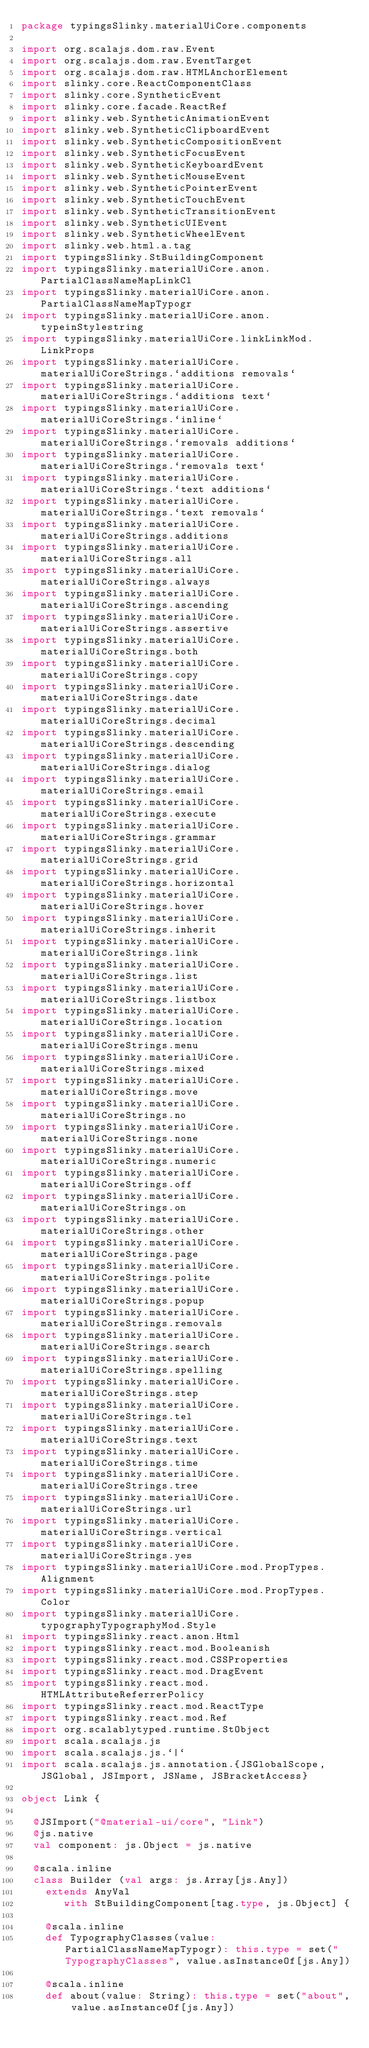Convert code to text. <code><loc_0><loc_0><loc_500><loc_500><_Scala_>package typingsSlinky.materialUiCore.components

import org.scalajs.dom.raw.Event
import org.scalajs.dom.raw.EventTarget
import org.scalajs.dom.raw.HTMLAnchorElement
import slinky.core.ReactComponentClass
import slinky.core.SyntheticEvent
import slinky.core.facade.ReactRef
import slinky.web.SyntheticAnimationEvent
import slinky.web.SyntheticClipboardEvent
import slinky.web.SyntheticCompositionEvent
import slinky.web.SyntheticFocusEvent
import slinky.web.SyntheticKeyboardEvent
import slinky.web.SyntheticMouseEvent
import slinky.web.SyntheticPointerEvent
import slinky.web.SyntheticTouchEvent
import slinky.web.SyntheticTransitionEvent
import slinky.web.SyntheticUIEvent
import slinky.web.SyntheticWheelEvent
import slinky.web.html.a.tag
import typingsSlinky.StBuildingComponent
import typingsSlinky.materialUiCore.anon.PartialClassNameMapLinkCl
import typingsSlinky.materialUiCore.anon.PartialClassNameMapTypogr
import typingsSlinky.materialUiCore.anon.typeinStylestring
import typingsSlinky.materialUiCore.linkLinkMod.LinkProps
import typingsSlinky.materialUiCore.materialUiCoreStrings.`additions removals`
import typingsSlinky.materialUiCore.materialUiCoreStrings.`additions text`
import typingsSlinky.materialUiCore.materialUiCoreStrings.`inline`
import typingsSlinky.materialUiCore.materialUiCoreStrings.`removals additions`
import typingsSlinky.materialUiCore.materialUiCoreStrings.`removals text`
import typingsSlinky.materialUiCore.materialUiCoreStrings.`text additions`
import typingsSlinky.materialUiCore.materialUiCoreStrings.`text removals`
import typingsSlinky.materialUiCore.materialUiCoreStrings.additions
import typingsSlinky.materialUiCore.materialUiCoreStrings.all
import typingsSlinky.materialUiCore.materialUiCoreStrings.always
import typingsSlinky.materialUiCore.materialUiCoreStrings.ascending
import typingsSlinky.materialUiCore.materialUiCoreStrings.assertive
import typingsSlinky.materialUiCore.materialUiCoreStrings.both
import typingsSlinky.materialUiCore.materialUiCoreStrings.copy
import typingsSlinky.materialUiCore.materialUiCoreStrings.date
import typingsSlinky.materialUiCore.materialUiCoreStrings.decimal
import typingsSlinky.materialUiCore.materialUiCoreStrings.descending
import typingsSlinky.materialUiCore.materialUiCoreStrings.dialog
import typingsSlinky.materialUiCore.materialUiCoreStrings.email
import typingsSlinky.materialUiCore.materialUiCoreStrings.execute
import typingsSlinky.materialUiCore.materialUiCoreStrings.grammar
import typingsSlinky.materialUiCore.materialUiCoreStrings.grid
import typingsSlinky.materialUiCore.materialUiCoreStrings.horizontal
import typingsSlinky.materialUiCore.materialUiCoreStrings.hover
import typingsSlinky.materialUiCore.materialUiCoreStrings.inherit
import typingsSlinky.materialUiCore.materialUiCoreStrings.link
import typingsSlinky.materialUiCore.materialUiCoreStrings.list
import typingsSlinky.materialUiCore.materialUiCoreStrings.listbox
import typingsSlinky.materialUiCore.materialUiCoreStrings.location
import typingsSlinky.materialUiCore.materialUiCoreStrings.menu
import typingsSlinky.materialUiCore.materialUiCoreStrings.mixed
import typingsSlinky.materialUiCore.materialUiCoreStrings.move
import typingsSlinky.materialUiCore.materialUiCoreStrings.no
import typingsSlinky.materialUiCore.materialUiCoreStrings.none
import typingsSlinky.materialUiCore.materialUiCoreStrings.numeric
import typingsSlinky.materialUiCore.materialUiCoreStrings.off
import typingsSlinky.materialUiCore.materialUiCoreStrings.on
import typingsSlinky.materialUiCore.materialUiCoreStrings.other
import typingsSlinky.materialUiCore.materialUiCoreStrings.page
import typingsSlinky.materialUiCore.materialUiCoreStrings.polite
import typingsSlinky.materialUiCore.materialUiCoreStrings.popup
import typingsSlinky.materialUiCore.materialUiCoreStrings.removals
import typingsSlinky.materialUiCore.materialUiCoreStrings.search
import typingsSlinky.materialUiCore.materialUiCoreStrings.spelling
import typingsSlinky.materialUiCore.materialUiCoreStrings.step
import typingsSlinky.materialUiCore.materialUiCoreStrings.tel
import typingsSlinky.materialUiCore.materialUiCoreStrings.text
import typingsSlinky.materialUiCore.materialUiCoreStrings.time
import typingsSlinky.materialUiCore.materialUiCoreStrings.tree
import typingsSlinky.materialUiCore.materialUiCoreStrings.url
import typingsSlinky.materialUiCore.materialUiCoreStrings.vertical
import typingsSlinky.materialUiCore.materialUiCoreStrings.yes
import typingsSlinky.materialUiCore.mod.PropTypes.Alignment
import typingsSlinky.materialUiCore.mod.PropTypes.Color
import typingsSlinky.materialUiCore.typographyTypographyMod.Style
import typingsSlinky.react.anon.Html
import typingsSlinky.react.mod.Booleanish
import typingsSlinky.react.mod.CSSProperties
import typingsSlinky.react.mod.DragEvent
import typingsSlinky.react.mod.HTMLAttributeReferrerPolicy
import typingsSlinky.react.mod.ReactType
import typingsSlinky.react.mod.Ref
import org.scalablytyped.runtime.StObject
import scala.scalajs.js
import scala.scalajs.js.`|`
import scala.scalajs.js.annotation.{JSGlobalScope, JSGlobal, JSImport, JSName, JSBracketAccess}

object Link {
  
  @JSImport("@material-ui/core", "Link")
  @js.native
  val component: js.Object = js.native
  
  @scala.inline
  class Builder (val args: js.Array[js.Any])
    extends AnyVal
       with StBuildingComponent[tag.type, js.Object] {
    
    @scala.inline
    def TypographyClasses(value: PartialClassNameMapTypogr): this.type = set("TypographyClasses", value.asInstanceOf[js.Any])
    
    @scala.inline
    def about(value: String): this.type = set("about", value.asInstanceOf[js.Any])
    </code> 